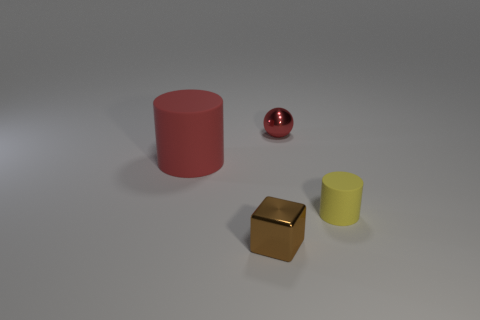There is a rubber object that is on the left side of the shiny object left of the metallic object behind the tiny block; how big is it?
Offer a very short reply. Large. What is the color of the object that is both to the left of the red shiny thing and right of the red matte thing?
Offer a very short reply. Brown. Do the brown thing and the cylinder that is left of the red metallic sphere have the same size?
Your response must be concise. No. Is there any other thing that is the same shape as the large red thing?
Your answer should be very brief. Yes. There is a small rubber thing that is the same shape as the big matte object; what is its color?
Provide a short and direct response. Yellow. Is the red shiny ball the same size as the brown object?
Your response must be concise. Yes. How many other objects are the same size as the red cylinder?
Provide a succinct answer. 0. How many things are either cylinders that are right of the big red object or tiny things that are on the left side of the red sphere?
Make the answer very short. 2. There is a red metallic thing that is the same size as the brown thing; what shape is it?
Provide a short and direct response. Sphere. What size is the red cylinder that is made of the same material as the yellow thing?
Your answer should be very brief. Large. 